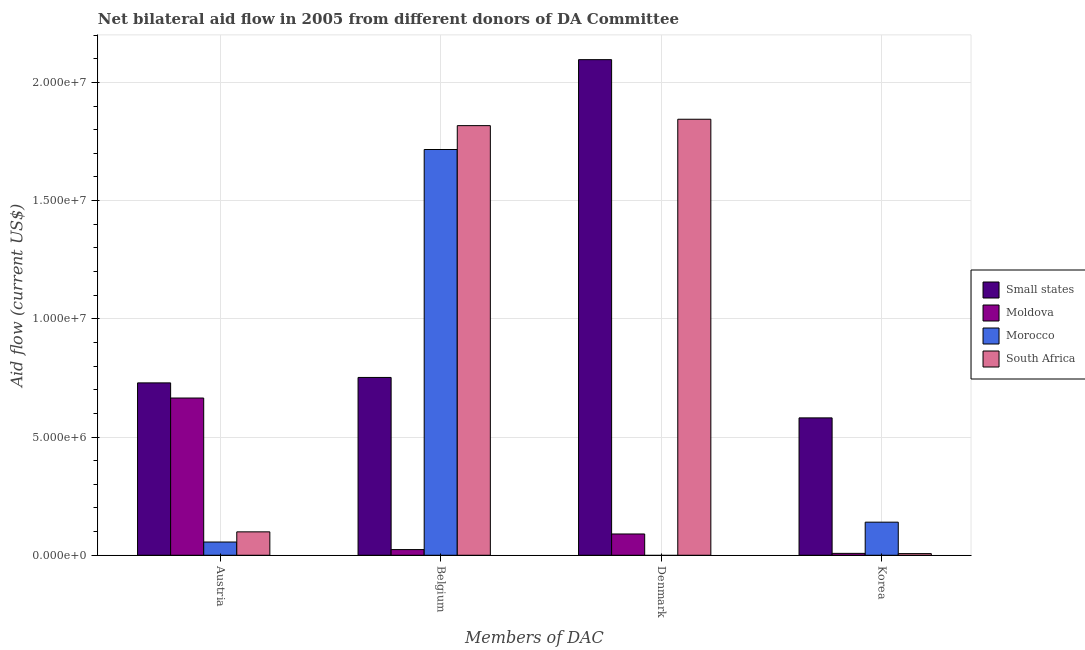How many different coloured bars are there?
Offer a very short reply. 4. How many groups of bars are there?
Ensure brevity in your answer.  4. How many bars are there on the 1st tick from the right?
Provide a short and direct response. 4. What is the amount of aid given by belgium in Small states?
Offer a terse response. 7.52e+06. Across all countries, what is the maximum amount of aid given by denmark?
Provide a succinct answer. 2.10e+07. In which country was the amount of aid given by belgium maximum?
Your answer should be compact. South Africa. What is the total amount of aid given by austria in the graph?
Give a very brief answer. 1.55e+07. What is the difference between the amount of aid given by austria in Small states and that in Moldova?
Your response must be concise. 6.40e+05. What is the difference between the amount of aid given by korea in Morocco and the amount of aid given by denmark in Small states?
Offer a very short reply. -1.96e+07. What is the average amount of aid given by belgium per country?
Give a very brief answer. 1.08e+07. What is the difference between the amount of aid given by denmark and amount of aid given by korea in Moldova?
Your answer should be very brief. 8.20e+05. In how many countries, is the amount of aid given by denmark greater than 1000000 US$?
Your answer should be very brief. 2. What is the ratio of the amount of aid given by denmark in Moldova to that in Small states?
Give a very brief answer. 0.04. Is the amount of aid given by austria in Small states less than that in Morocco?
Provide a succinct answer. No. Is the difference between the amount of aid given by belgium in South Africa and Small states greater than the difference between the amount of aid given by denmark in South Africa and Small states?
Your answer should be compact. Yes. What is the difference between the highest and the second highest amount of aid given by denmark?
Ensure brevity in your answer.  2.52e+06. What is the difference between the highest and the lowest amount of aid given by austria?
Your response must be concise. 6.73e+06. In how many countries, is the amount of aid given by denmark greater than the average amount of aid given by denmark taken over all countries?
Give a very brief answer. 2. Is the sum of the amount of aid given by belgium in Small states and South Africa greater than the maximum amount of aid given by austria across all countries?
Your response must be concise. Yes. Is it the case that in every country, the sum of the amount of aid given by denmark and amount of aid given by belgium is greater than the sum of amount of aid given by korea and amount of aid given by austria?
Make the answer very short. No. Is it the case that in every country, the sum of the amount of aid given by austria and amount of aid given by belgium is greater than the amount of aid given by denmark?
Offer a terse response. No. What is the difference between two consecutive major ticks on the Y-axis?
Keep it short and to the point. 5.00e+06. Are the values on the major ticks of Y-axis written in scientific E-notation?
Your answer should be very brief. Yes. Does the graph contain any zero values?
Ensure brevity in your answer.  Yes. Does the graph contain grids?
Your answer should be very brief. Yes. What is the title of the graph?
Provide a short and direct response. Net bilateral aid flow in 2005 from different donors of DA Committee. What is the label or title of the X-axis?
Provide a succinct answer. Members of DAC. What is the Aid flow (current US$) in Small states in Austria?
Ensure brevity in your answer.  7.29e+06. What is the Aid flow (current US$) of Moldova in Austria?
Give a very brief answer. 6.65e+06. What is the Aid flow (current US$) in Morocco in Austria?
Your response must be concise. 5.60e+05. What is the Aid flow (current US$) of South Africa in Austria?
Make the answer very short. 9.90e+05. What is the Aid flow (current US$) of Small states in Belgium?
Offer a very short reply. 7.52e+06. What is the Aid flow (current US$) of Morocco in Belgium?
Provide a short and direct response. 1.72e+07. What is the Aid flow (current US$) of South Africa in Belgium?
Keep it short and to the point. 1.82e+07. What is the Aid flow (current US$) of Small states in Denmark?
Keep it short and to the point. 2.10e+07. What is the Aid flow (current US$) of Moldova in Denmark?
Provide a short and direct response. 9.00e+05. What is the Aid flow (current US$) of South Africa in Denmark?
Ensure brevity in your answer.  1.84e+07. What is the Aid flow (current US$) in Small states in Korea?
Provide a short and direct response. 5.81e+06. What is the Aid flow (current US$) in Morocco in Korea?
Your response must be concise. 1.40e+06. What is the Aid flow (current US$) in South Africa in Korea?
Offer a very short reply. 7.00e+04. Across all Members of DAC, what is the maximum Aid flow (current US$) of Small states?
Provide a succinct answer. 2.10e+07. Across all Members of DAC, what is the maximum Aid flow (current US$) in Moldova?
Provide a short and direct response. 6.65e+06. Across all Members of DAC, what is the maximum Aid flow (current US$) in Morocco?
Make the answer very short. 1.72e+07. Across all Members of DAC, what is the maximum Aid flow (current US$) of South Africa?
Give a very brief answer. 1.84e+07. Across all Members of DAC, what is the minimum Aid flow (current US$) in Small states?
Keep it short and to the point. 5.81e+06. What is the total Aid flow (current US$) in Small states in the graph?
Give a very brief answer. 4.16e+07. What is the total Aid flow (current US$) in Moldova in the graph?
Ensure brevity in your answer.  7.87e+06. What is the total Aid flow (current US$) in Morocco in the graph?
Provide a succinct answer. 1.91e+07. What is the total Aid flow (current US$) of South Africa in the graph?
Offer a terse response. 3.77e+07. What is the difference between the Aid flow (current US$) in Small states in Austria and that in Belgium?
Give a very brief answer. -2.30e+05. What is the difference between the Aid flow (current US$) of Moldova in Austria and that in Belgium?
Give a very brief answer. 6.41e+06. What is the difference between the Aid flow (current US$) of Morocco in Austria and that in Belgium?
Provide a short and direct response. -1.66e+07. What is the difference between the Aid flow (current US$) of South Africa in Austria and that in Belgium?
Keep it short and to the point. -1.72e+07. What is the difference between the Aid flow (current US$) of Small states in Austria and that in Denmark?
Offer a terse response. -1.37e+07. What is the difference between the Aid flow (current US$) in Moldova in Austria and that in Denmark?
Your answer should be very brief. 5.75e+06. What is the difference between the Aid flow (current US$) in South Africa in Austria and that in Denmark?
Offer a terse response. -1.74e+07. What is the difference between the Aid flow (current US$) in Small states in Austria and that in Korea?
Offer a terse response. 1.48e+06. What is the difference between the Aid flow (current US$) of Moldova in Austria and that in Korea?
Keep it short and to the point. 6.57e+06. What is the difference between the Aid flow (current US$) in Morocco in Austria and that in Korea?
Provide a succinct answer. -8.40e+05. What is the difference between the Aid flow (current US$) of South Africa in Austria and that in Korea?
Your answer should be very brief. 9.20e+05. What is the difference between the Aid flow (current US$) of Small states in Belgium and that in Denmark?
Provide a succinct answer. -1.34e+07. What is the difference between the Aid flow (current US$) of Moldova in Belgium and that in Denmark?
Your response must be concise. -6.60e+05. What is the difference between the Aid flow (current US$) of South Africa in Belgium and that in Denmark?
Offer a very short reply. -2.70e+05. What is the difference between the Aid flow (current US$) of Small states in Belgium and that in Korea?
Provide a short and direct response. 1.71e+06. What is the difference between the Aid flow (current US$) in Moldova in Belgium and that in Korea?
Your answer should be compact. 1.60e+05. What is the difference between the Aid flow (current US$) of Morocco in Belgium and that in Korea?
Offer a terse response. 1.58e+07. What is the difference between the Aid flow (current US$) of South Africa in Belgium and that in Korea?
Keep it short and to the point. 1.81e+07. What is the difference between the Aid flow (current US$) in Small states in Denmark and that in Korea?
Offer a terse response. 1.52e+07. What is the difference between the Aid flow (current US$) in Moldova in Denmark and that in Korea?
Your answer should be compact. 8.20e+05. What is the difference between the Aid flow (current US$) in South Africa in Denmark and that in Korea?
Keep it short and to the point. 1.84e+07. What is the difference between the Aid flow (current US$) in Small states in Austria and the Aid flow (current US$) in Moldova in Belgium?
Your response must be concise. 7.05e+06. What is the difference between the Aid flow (current US$) in Small states in Austria and the Aid flow (current US$) in Morocco in Belgium?
Your answer should be compact. -9.87e+06. What is the difference between the Aid flow (current US$) in Small states in Austria and the Aid flow (current US$) in South Africa in Belgium?
Offer a very short reply. -1.09e+07. What is the difference between the Aid flow (current US$) in Moldova in Austria and the Aid flow (current US$) in Morocco in Belgium?
Offer a terse response. -1.05e+07. What is the difference between the Aid flow (current US$) in Moldova in Austria and the Aid flow (current US$) in South Africa in Belgium?
Provide a succinct answer. -1.15e+07. What is the difference between the Aid flow (current US$) of Morocco in Austria and the Aid flow (current US$) of South Africa in Belgium?
Your answer should be very brief. -1.76e+07. What is the difference between the Aid flow (current US$) of Small states in Austria and the Aid flow (current US$) of Moldova in Denmark?
Offer a terse response. 6.39e+06. What is the difference between the Aid flow (current US$) in Small states in Austria and the Aid flow (current US$) in South Africa in Denmark?
Give a very brief answer. -1.12e+07. What is the difference between the Aid flow (current US$) of Moldova in Austria and the Aid flow (current US$) of South Africa in Denmark?
Your answer should be very brief. -1.18e+07. What is the difference between the Aid flow (current US$) of Morocco in Austria and the Aid flow (current US$) of South Africa in Denmark?
Give a very brief answer. -1.79e+07. What is the difference between the Aid flow (current US$) of Small states in Austria and the Aid flow (current US$) of Moldova in Korea?
Provide a succinct answer. 7.21e+06. What is the difference between the Aid flow (current US$) of Small states in Austria and the Aid flow (current US$) of Morocco in Korea?
Your answer should be compact. 5.89e+06. What is the difference between the Aid flow (current US$) of Small states in Austria and the Aid flow (current US$) of South Africa in Korea?
Provide a short and direct response. 7.22e+06. What is the difference between the Aid flow (current US$) in Moldova in Austria and the Aid flow (current US$) in Morocco in Korea?
Provide a short and direct response. 5.25e+06. What is the difference between the Aid flow (current US$) of Moldova in Austria and the Aid flow (current US$) of South Africa in Korea?
Your answer should be very brief. 6.58e+06. What is the difference between the Aid flow (current US$) of Morocco in Austria and the Aid flow (current US$) of South Africa in Korea?
Make the answer very short. 4.90e+05. What is the difference between the Aid flow (current US$) of Small states in Belgium and the Aid flow (current US$) of Moldova in Denmark?
Provide a succinct answer. 6.62e+06. What is the difference between the Aid flow (current US$) of Small states in Belgium and the Aid flow (current US$) of South Africa in Denmark?
Give a very brief answer. -1.09e+07. What is the difference between the Aid flow (current US$) of Moldova in Belgium and the Aid flow (current US$) of South Africa in Denmark?
Provide a short and direct response. -1.82e+07. What is the difference between the Aid flow (current US$) of Morocco in Belgium and the Aid flow (current US$) of South Africa in Denmark?
Ensure brevity in your answer.  -1.28e+06. What is the difference between the Aid flow (current US$) of Small states in Belgium and the Aid flow (current US$) of Moldova in Korea?
Give a very brief answer. 7.44e+06. What is the difference between the Aid flow (current US$) in Small states in Belgium and the Aid flow (current US$) in Morocco in Korea?
Provide a succinct answer. 6.12e+06. What is the difference between the Aid flow (current US$) of Small states in Belgium and the Aid flow (current US$) of South Africa in Korea?
Make the answer very short. 7.45e+06. What is the difference between the Aid flow (current US$) in Moldova in Belgium and the Aid flow (current US$) in Morocco in Korea?
Make the answer very short. -1.16e+06. What is the difference between the Aid flow (current US$) of Moldova in Belgium and the Aid flow (current US$) of South Africa in Korea?
Make the answer very short. 1.70e+05. What is the difference between the Aid flow (current US$) of Morocco in Belgium and the Aid flow (current US$) of South Africa in Korea?
Offer a terse response. 1.71e+07. What is the difference between the Aid flow (current US$) of Small states in Denmark and the Aid flow (current US$) of Moldova in Korea?
Your answer should be compact. 2.09e+07. What is the difference between the Aid flow (current US$) of Small states in Denmark and the Aid flow (current US$) of Morocco in Korea?
Your answer should be compact. 1.96e+07. What is the difference between the Aid flow (current US$) in Small states in Denmark and the Aid flow (current US$) in South Africa in Korea?
Make the answer very short. 2.09e+07. What is the difference between the Aid flow (current US$) in Moldova in Denmark and the Aid flow (current US$) in Morocco in Korea?
Give a very brief answer. -5.00e+05. What is the difference between the Aid flow (current US$) in Moldova in Denmark and the Aid flow (current US$) in South Africa in Korea?
Ensure brevity in your answer.  8.30e+05. What is the average Aid flow (current US$) of Small states per Members of DAC?
Provide a succinct answer. 1.04e+07. What is the average Aid flow (current US$) of Moldova per Members of DAC?
Your response must be concise. 1.97e+06. What is the average Aid flow (current US$) of Morocco per Members of DAC?
Provide a short and direct response. 4.78e+06. What is the average Aid flow (current US$) in South Africa per Members of DAC?
Provide a succinct answer. 9.42e+06. What is the difference between the Aid flow (current US$) in Small states and Aid flow (current US$) in Moldova in Austria?
Offer a terse response. 6.40e+05. What is the difference between the Aid flow (current US$) in Small states and Aid flow (current US$) in Morocco in Austria?
Ensure brevity in your answer.  6.73e+06. What is the difference between the Aid flow (current US$) in Small states and Aid flow (current US$) in South Africa in Austria?
Provide a succinct answer. 6.30e+06. What is the difference between the Aid flow (current US$) of Moldova and Aid flow (current US$) of Morocco in Austria?
Offer a terse response. 6.09e+06. What is the difference between the Aid flow (current US$) of Moldova and Aid flow (current US$) of South Africa in Austria?
Your answer should be compact. 5.66e+06. What is the difference between the Aid flow (current US$) in Morocco and Aid flow (current US$) in South Africa in Austria?
Give a very brief answer. -4.30e+05. What is the difference between the Aid flow (current US$) of Small states and Aid flow (current US$) of Moldova in Belgium?
Make the answer very short. 7.28e+06. What is the difference between the Aid flow (current US$) in Small states and Aid flow (current US$) in Morocco in Belgium?
Your answer should be compact. -9.64e+06. What is the difference between the Aid flow (current US$) of Small states and Aid flow (current US$) of South Africa in Belgium?
Offer a very short reply. -1.06e+07. What is the difference between the Aid flow (current US$) in Moldova and Aid flow (current US$) in Morocco in Belgium?
Provide a succinct answer. -1.69e+07. What is the difference between the Aid flow (current US$) in Moldova and Aid flow (current US$) in South Africa in Belgium?
Provide a short and direct response. -1.79e+07. What is the difference between the Aid flow (current US$) in Morocco and Aid flow (current US$) in South Africa in Belgium?
Keep it short and to the point. -1.01e+06. What is the difference between the Aid flow (current US$) of Small states and Aid flow (current US$) of Moldova in Denmark?
Ensure brevity in your answer.  2.01e+07. What is the difference between the Aid flow (current US$) of Small states and Aid flow (current US$) of South Africa in Denmark?
Keep it short and to the point. 2.52e+06. What is the difference between the Aid flow (current US$) in Moldova and Aid flow (current US$) in South Africa in Denmark?
Provide a succinct answer. -1.75e+07. What is the difference between the Aid flow (current US$) in Small states and Aid flow (current US$) in Moldova in Korea?
Make the answer very short. 5.73e+06. What is the difference between the Aid flow (current US$) of Small states and Aid flow (current US$) of Morocco in Korea?
Provide a short and direct response. 4.41e+06. What is the difference between the Aid flow (current US$) of Small states and Aid flow (current US$) of South Africa in Korea?
Your answer should be very brief. 5.74e+06. What is the difference between the Aid flow (current US$) of Moldova and Aid flow (current US$) of Morocco in Korea?
Offer a very short reply. -1.32e+06. What is the difference between the Aid flow (current US$) of Morocco and Aid flow (current US$) of South Africa in Korea?
Keep it short and to the point. 1.33e+06. What is the ratio of the Aid flow (current US$) of Small states in Austria to that in Belgium?
Ensure brevity in your answer.  0.97. What is the ratio of the Aid flow (current US$) of Moldova in Austria to that in Belgium?
Make the answer very short. 27.71. What is the ratio of the Aid flow (current US$) of Morocco in Austria to that in Belgium?
Your response must be concise. 0.03. What is the ratio of the Aid flow (current US$) in South Africa in Austria to that in Belgium?
Provide a short and direct response. 0.05. What is the ratio of the Aid flow (current US$) of Small states in Austria to that in Denmark?
Give a very brief answer. 0.35. What is the ratio of the Aid flow (current US$) of Moldova in Austria to that in Denmark?
Provide a short and direct response. 7.39. What is the ratio of the Aid flow (current US$) in South Africa in Austria to that in Denmark?
Provide a short and direct response. 0.05. What is the ratio of the Aid flow (current US$) in Small states in Austria to that in Korea?
Give a very brief answer. 1.25. What is the ratio of the Aid flow (current US$) of Moldova in Austria to that in Korea?
Give a very brief answer. 83.12. What is the ratio of the Aid flow (current US$) of Morocco in Austria to that in Korea?
Give a very brief answer. 0.4. What is the ratio of the Aid flow (current US$) of South Africa in Austria to that in Korea?
Your answer should be compact. 14.14. What is the ratio of the Aid flow (current US$) in Small states in Belgium to that in Denmark?
Ensure brevity in your answer.  0.36. What is the ratio of the Aid flow (current US$) of Moldova in Belgium to that in Denmark?
Keep it short and to the point. 0.27. What is the ratio of the Aid flow (current US$) in South Africa in Belgium to that in Denmark?
Offer a very short reply. 0.99. What is the ratio of the Aid flow (current US$) of Small states in Belgium to that in Korea?
Make the answer very short. 1.29. What is the ratio of the Aid flow (current US$) in Moldova in Belgium to that in Korea?
Make the answer very short. 3. What is the ratio of the Aid flow (current US$) in Morocco in Belgium to that in Korea?
Your response must be concise. 12.26. What is the ratio of the Aid flow (current US$) in South Africa in Belgium to that in Korea?
Your response must be concise. 259.57. What is the ratio of the Aid flow (current US$) in Small states in Denmark to that in Korea?
Give a very brief answer. 3.61. What is the ratio of the Aid flow (current US$) of Moldova in Denmark to that in Korea?
Make the answer very short. 11.25. What is the ratio of the Aid flow (current US$) in South Africa in Denmark to that in Korea?
Provide a short and direct response. 263.43. What is the difference between the highest and the second highest Aid flow (current US$) in Small states?
Your answer should be very brief. 1.34e+07. What is the difference between the highest and the second highest Aid flow (current US$) of Moldova?
Provide a succinct answer. 5.75e+06. What is the difference between the highest and the second highest Aid flow (current US$) of Morocco?
Your answer should be compact. 1.58e+07. What is the difference between the highest and the lowest Aid flow (current US$) of Small states?
Give a very brief answer. 1.52e+07. What is the difference between the highest and the lowest Aid flow (current US$) of Moldova?
Give a very brief answer. 6.57e+06. What is the difference between the highest and the lowest Aid flow (current US$) of Morocco?
Your response must be concise. 1.72e+07. What is the difference between the highest and the lowest Aid flow (current US$) in South Africa?
Offer a terse response. 1.84e+07. 